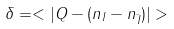Convert formula to latex. <formula><loc_0><loc_0><loc_500><loc_500>\delta = < | Q - ( n _ { I } - n _ { \bar { I } } ) | ></formula> 